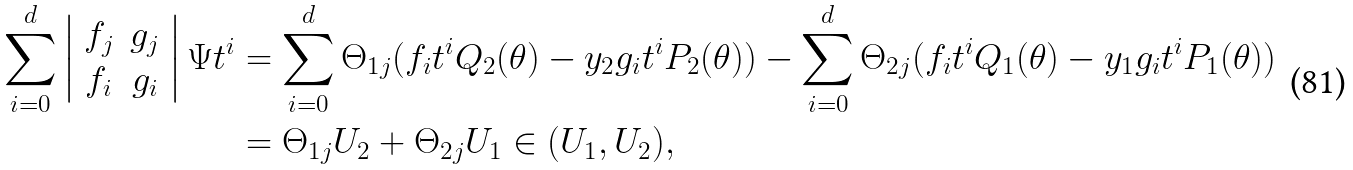Convert formula to latex. <formula><loc_0><loc_0><loc_500><loc_500>\sum _ { i = 0 } ^ { d } \left | \begin{array} { c c } f _ { j } & g _ { j } \\ f _ { i } & g _ { i } \\ \end{array} \right | \Psi t ^ { i } & = \sum _ { i = 0 } ^ { d } \Theta _ { 1 j } ( f _ { i } t ^ { i } { Q } _ { 2 } ( \theta ) - y _ { 2 } g _ { i } t ^ { i } { P } _ { 2 } ( \theta ) ) - \sum _ { i = 0 } ^ { d } \Theta _ { 2 j } ( f _ { i } t ^ { i } { Q } _ { 1 } ( \theta ) - y _ { 1 } g _ { i } t ^ { i } { P } _ { 1 } ( \theta ) ) \\ & = \Theta _ { 1 j } U _ { 2 } + \Theta _ { 2 j } U _ { 1 } \in ( U _ { 1 } , U _ { 2 } ) ,</formula> 